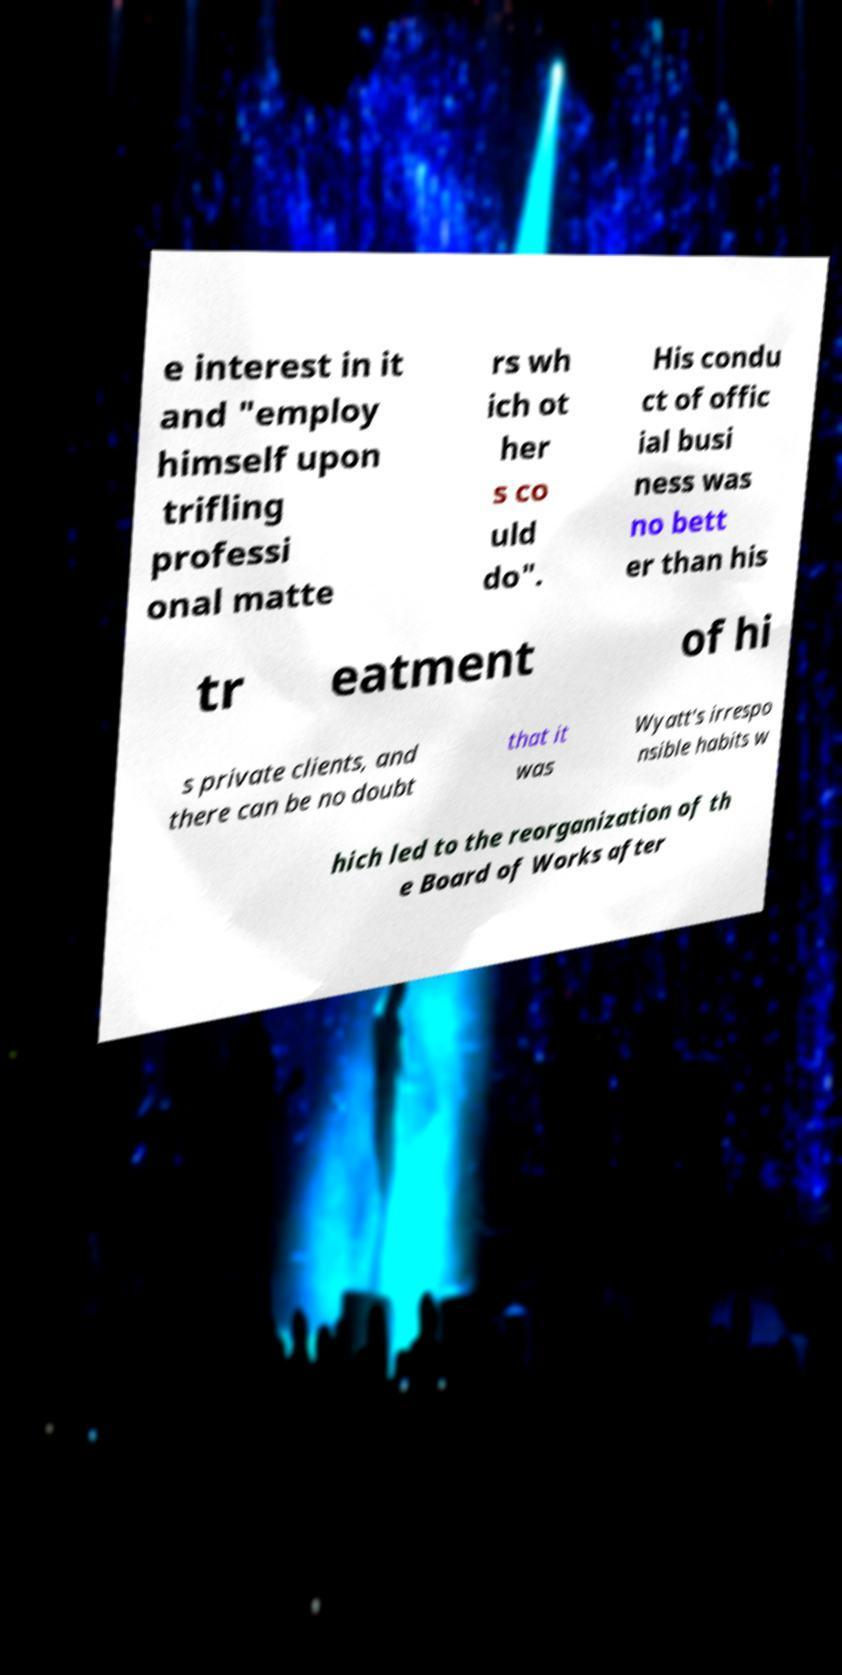Can you accurately transcribe the text from the provided image for me? e interest in it and "employ himself upon trifling professi onal matte rs wh ich ot her s co uld do". His condu ct of offic ial busi ness was no bett er than his tr eatment of hi s private clients, and there can be no doubt that it was Wyatt's irrespo nsible habits w hich led to the reorganization of th e Board of Works after 